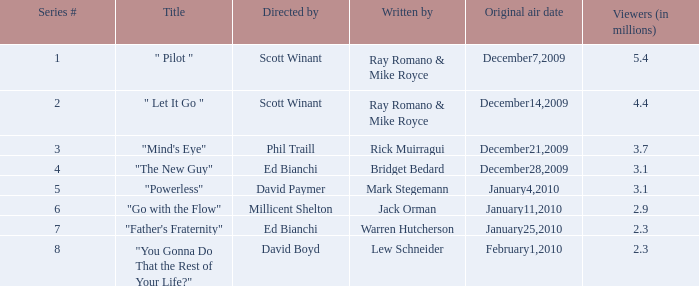What was the audience size (in millions) for episode 1? 5.4. 